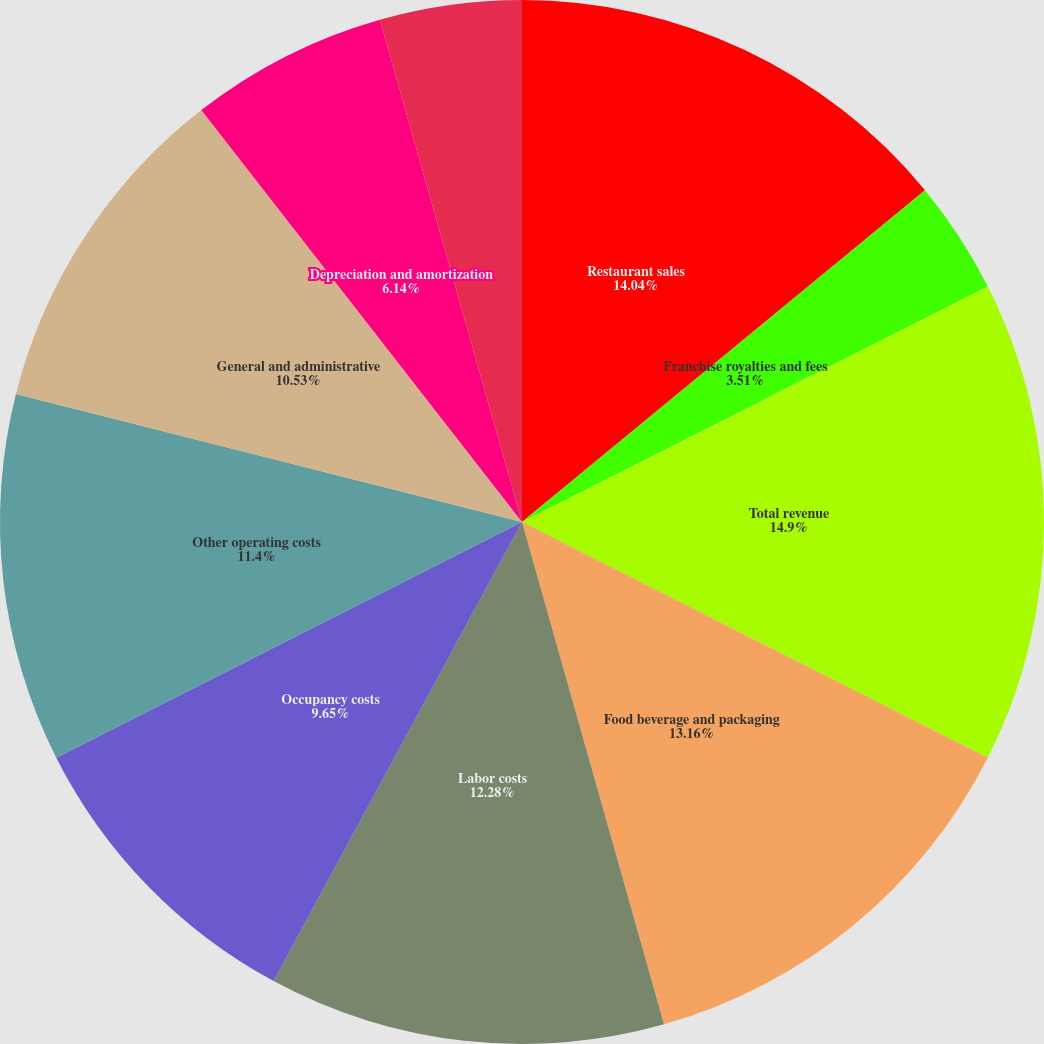Convert chart. <chart><loc_0><loc_0><loc_500><loc_500><pie_chart><fcel>Restaurant sales<fcel>Franchise royalties and fees<fcel>Total revenue<fcel>Food beverage and packaging<fcel>Labor costs<fcel>Occupancy costs<fcel>Other operating costs<fcel>General and administrative<fcel>Depreciation and amortization<fcel>Pre-opening costs<nl><fcel>14.04%<fcel>3.51%<fcel>14.91%<fcel>13.16%<fcel>12.28%<fcel>9.65%<fcel>11.4%<fcel>10.53%<fcel>6.14%<fcel>4.39%<nl></chart> 